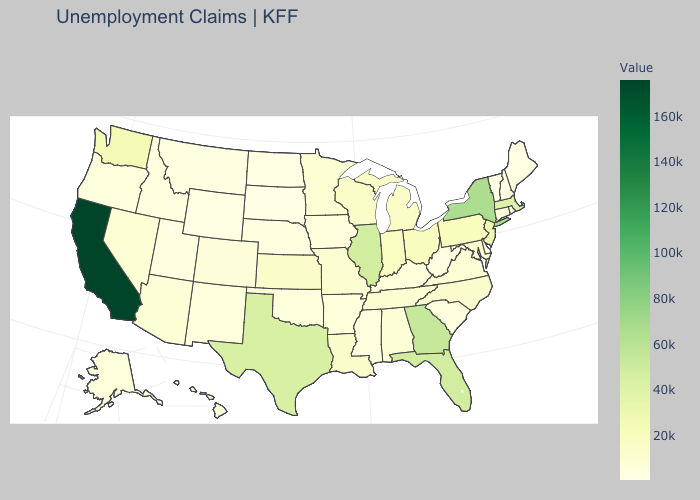Which states have the lowest value in the USA?
Write a very short answer. South Dakota. Which states have the highest value in the USA?
Write a very short answer. California. Does California have the highest value in the USA?
Short answer required. Yes. Among the states that border Florida , which have the highest value?
Short answer required. Georgia. 